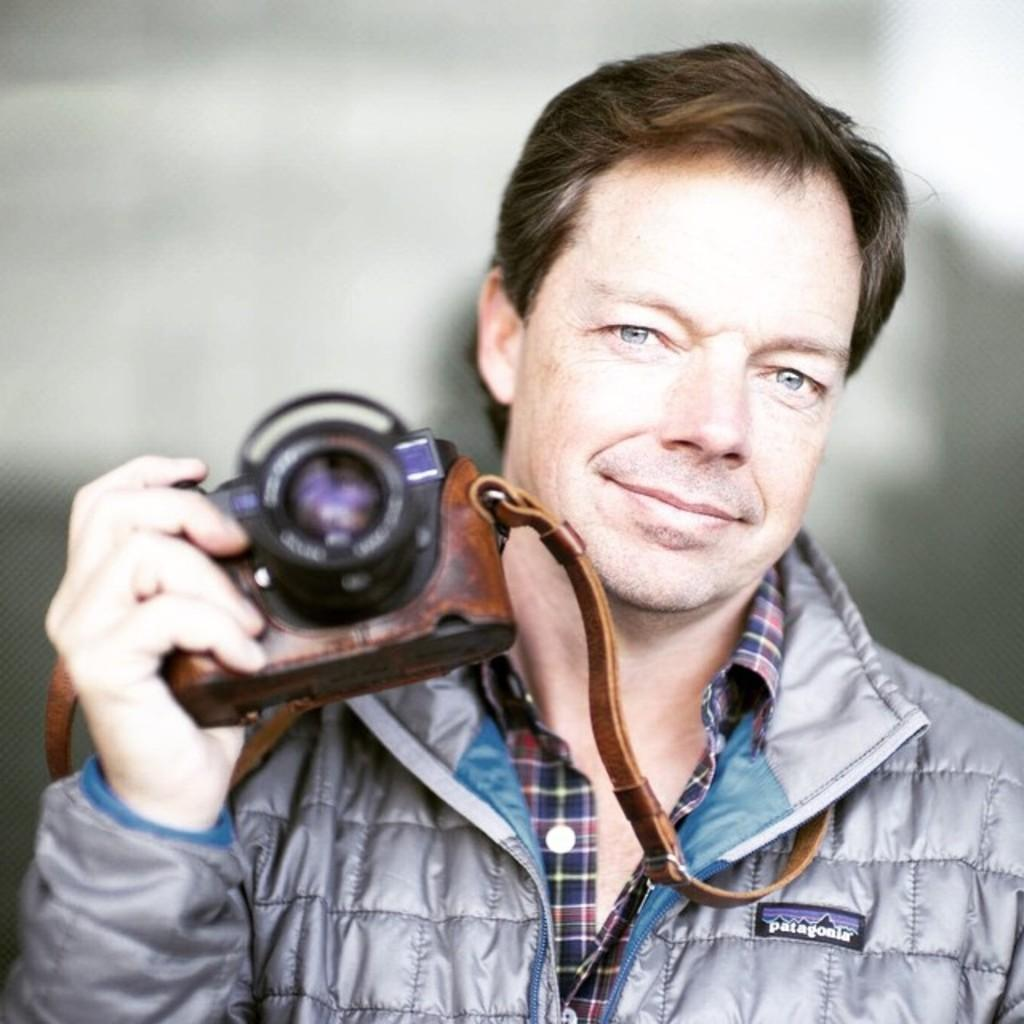Who is the main subject in the image? There is a man in the image. What is the man wearing? The man is wearing a gray jacket. What is the man holding in his hand? The man is holding a camera in his hand. What type of owl can be seen perched on the man's shoulder in the image? There is no owl present in the image; the man is holding a camera in his hand. 